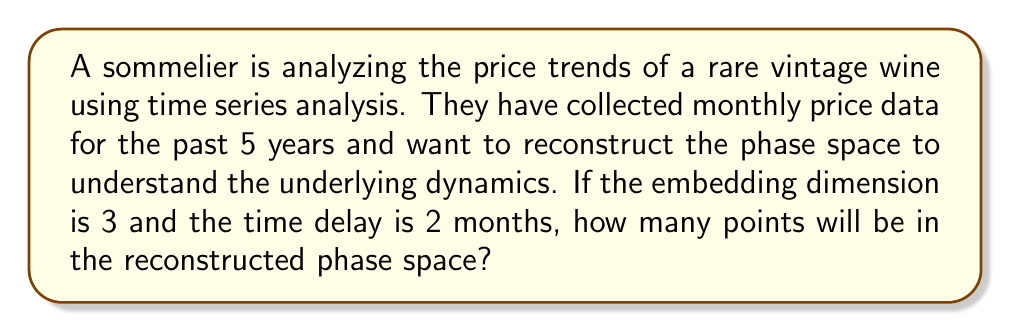Solve this math problem. Let's approach this step-by-step:

1) First, we need to calculate the total number of data points in the original time series:
   - 5 years of monthly data
   - Number of data points = 5 years × 12 months/year = 60 data points

2) In phase space reconstruction, we create vectors using the time delay method:
   - Embedding dimension (m) = 3
   - Time delay (τ) = 2 months

3) Each vector in the reconstructed phase space will be of the form:
   $$(x(t), x(t+τ), x(t+2τ))$$

4) The number of complete vectors we can form depends on how many "shifts" we can make while still having enough data points to form a complete vector.

5) The last point in the original time series that can be used as the start of a vector is:
   60 - 2(3-1) = 56

6) Therefore, we can form vectors starting from points 1 to 56 in the original time series.

7) The number of points in the reconstructed phase space is thus:
   56 - 1 + 1 = 56 (we add 1 because we count the starting point)
Answer: 56 